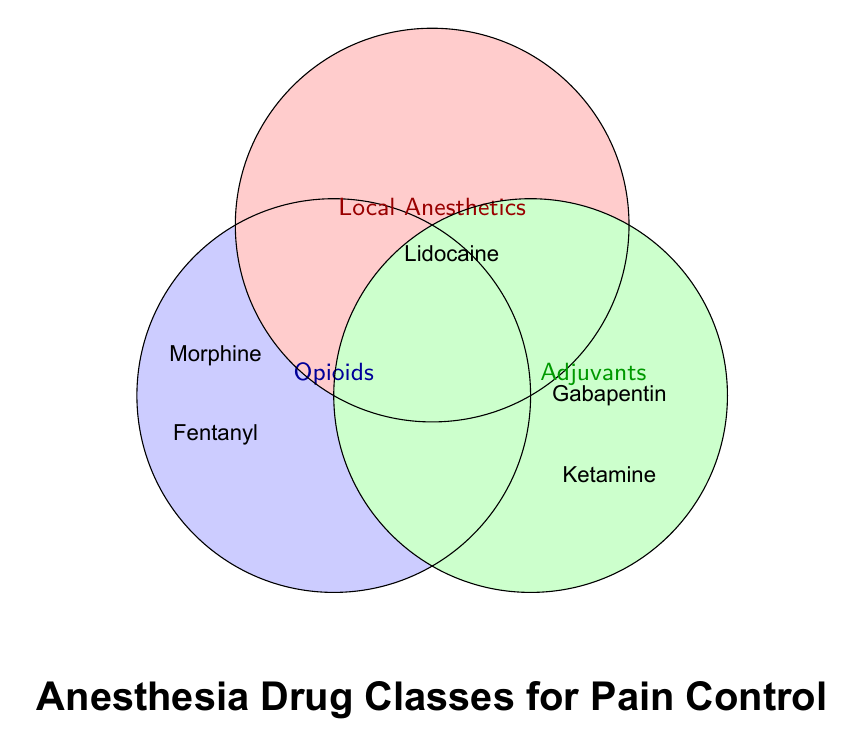What are the three drug classes represented in the Venn diagram? The Venn diagram shows three labeled circles, each representing a drug class. The classes are indicated as Opioids in blue, Local Anesthetics in red, and Adjuvants in green.
Answer: Opioids, Local Anesthetics, Adjuvants Which drugs fall under the Opioids category? The circle labeled Opioids in blue contains multiple drug names. Carefully reading the names inside this circle reveals Morphine, Fentanyl, Hydromorphone, Oxycodone, Methadone, and Remifentanil.
Answer: Morphine, Fentanyl, Hydromorphone, Oxycodone, Methadone, Remifentanil Where is Lidocaine categorized? Lidocaine is found inside the red circle labeled Local Anesthetics, which indicates this is its category.
Answer: Local Anesthetics How many drugs are categorized under Adjuvants? Observing the list of drugs inside the green circle labeled Adjuvants reveals four drugs: Gabapentin, Ketamine, Clonidine, and Pregabalin.
Answer: Four Which drug classes overlap with Gabapentin? Gabapentin is positioned within the green circle labeled Adjuvants without overlapping other circles, indicating that Gabapentin does not share any other category.
Answer: Adjuvants only Compare the number of drugs in the Opioids and Local Anesthetics categories. Which has more? The blue circle labeled Opioids contains six drugs, whereas the red circle labeled Local Anesthetics contains only two drugs. Six is greater than two, so Opioids have more drugs.
Answer: Opioids Is Ketamine found in a single category or multiple categories? Ketamine is found solely within the green circle labeled Adjuvants, which indicates it is not categorized under any other class.
Answer: Single category (Adjuvants) Which category does not have any drugs that overlap with other categories? No drugs overlap between the circles, so each category (Opioids, Local Anesthetics, Adjuvants) remains distinct without intersections in this diagram.
Answer: All categories Are there any drugs listed in more than one category? Examining the Venn diagram shows each drug is listed distinctly within one of the three circles without any overlaps or intersections between them.
Answer: No 